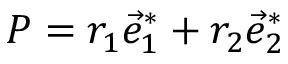<formula> <loc_0><loc_0><loc_500><loc_500>P = r _ { 1 } \vec { e } _ { 1 } ^ { * } + r _ { 2 } \vec { e } _ { 2 } ^ { * }</formula> 